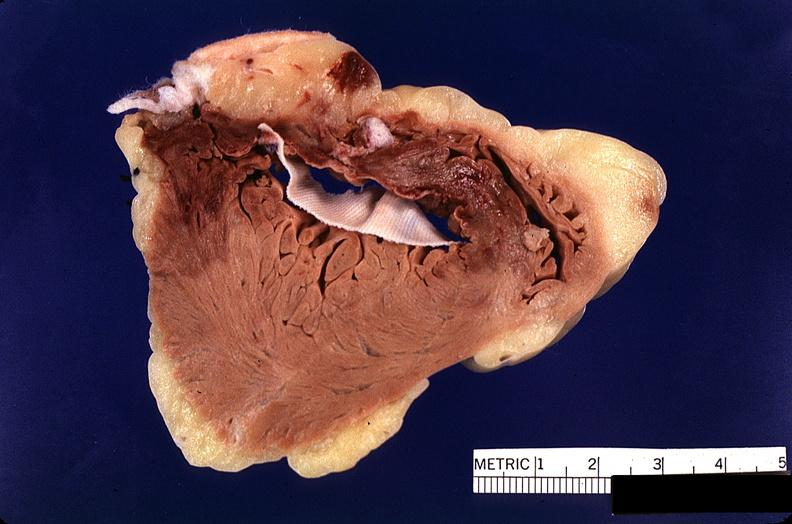does this image show heart, myocardial infarction, surgery to repair interventricular septum rupture?
Answer the question using a single word or phrase. Yes 